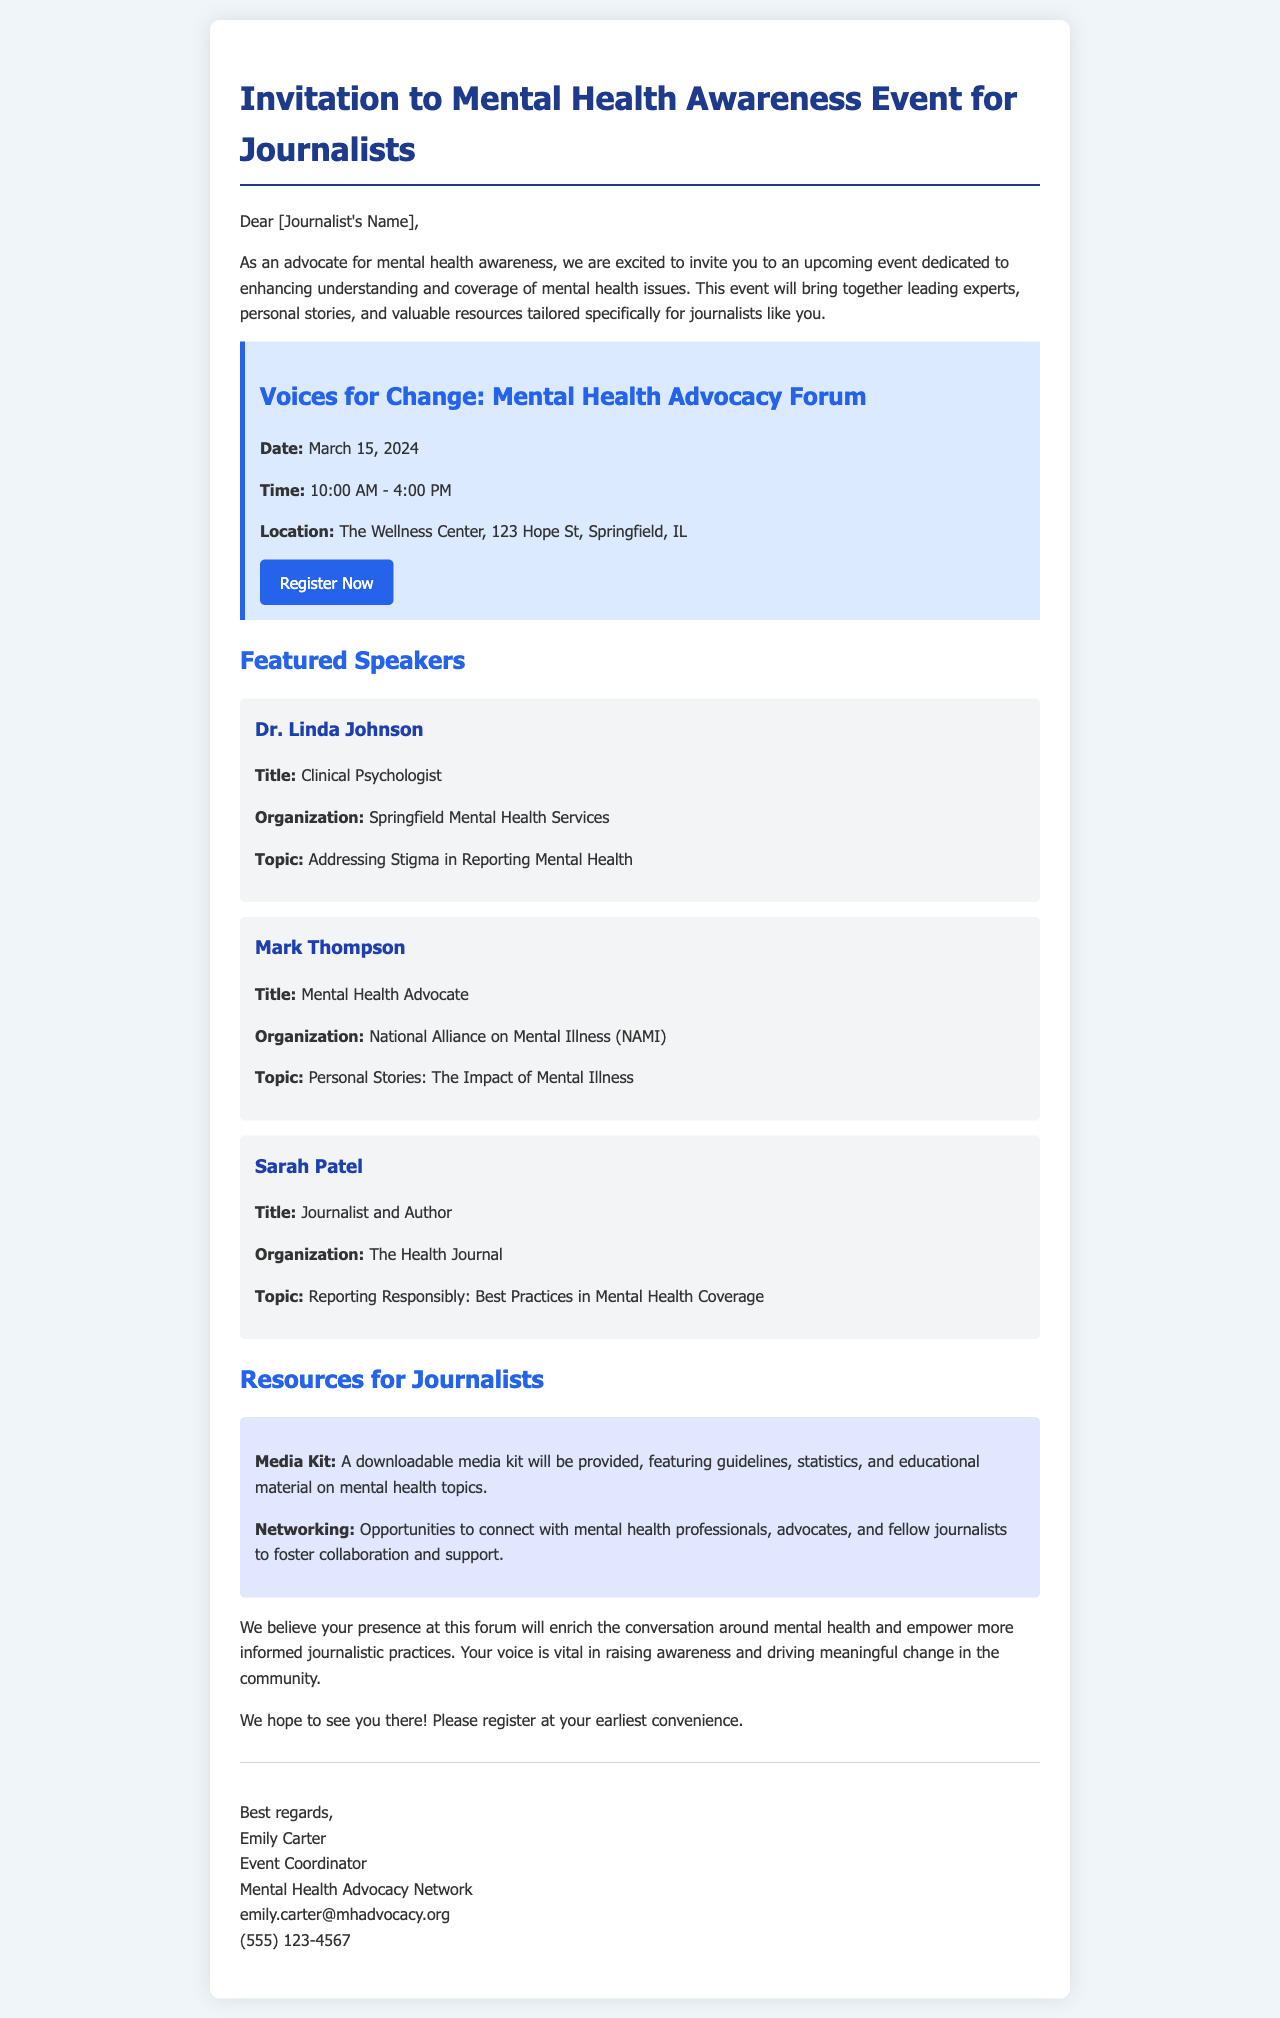What is the title of the event? The title of the event is stated clearly in the document under the event details section.
Answer: Voices for Change: Mental Health Advocacy Forum What is the date of the event? The date is mentioned in the event details section, providing clarity on when the event will occur.
Answer: March 15, 2024 Who is one of the featured speakers? The document lists several speakers; this question focuses on retrieving information about any one of them.
Answer: Dr. Linda Johnson What organization does Mark Thompson represent? The document specifies the organization each speaker is associated with, allowing for an easy reference to answer this question.
Answer: National Alliance on Mental Illness (NAMI) What is one of the topics Dr. Linda Johnson will address? The specific topic is mentioned directly under each speaker's description, making it clear and accessible.
Answer: Addressing Stigma in Reporting Mental Health What opportunities will be available for journalists at the event? The document describes various resources and networking opportunities provided specifically for journalists attending the event.
Answer: Networking Who is the event coordinator? The signature section of the document indicates who organized the event, allowing for easy retrieval of the name.
Answer: Emily Carter What time does the event start? The time is explicitly mentioned in the event details, ensuring a quick answer to this inquiry.
Answer: 10:00 AM What type of document is this? The format and content detail indicate the purpose and characteristics of this communication.
Answer: Invitation email 